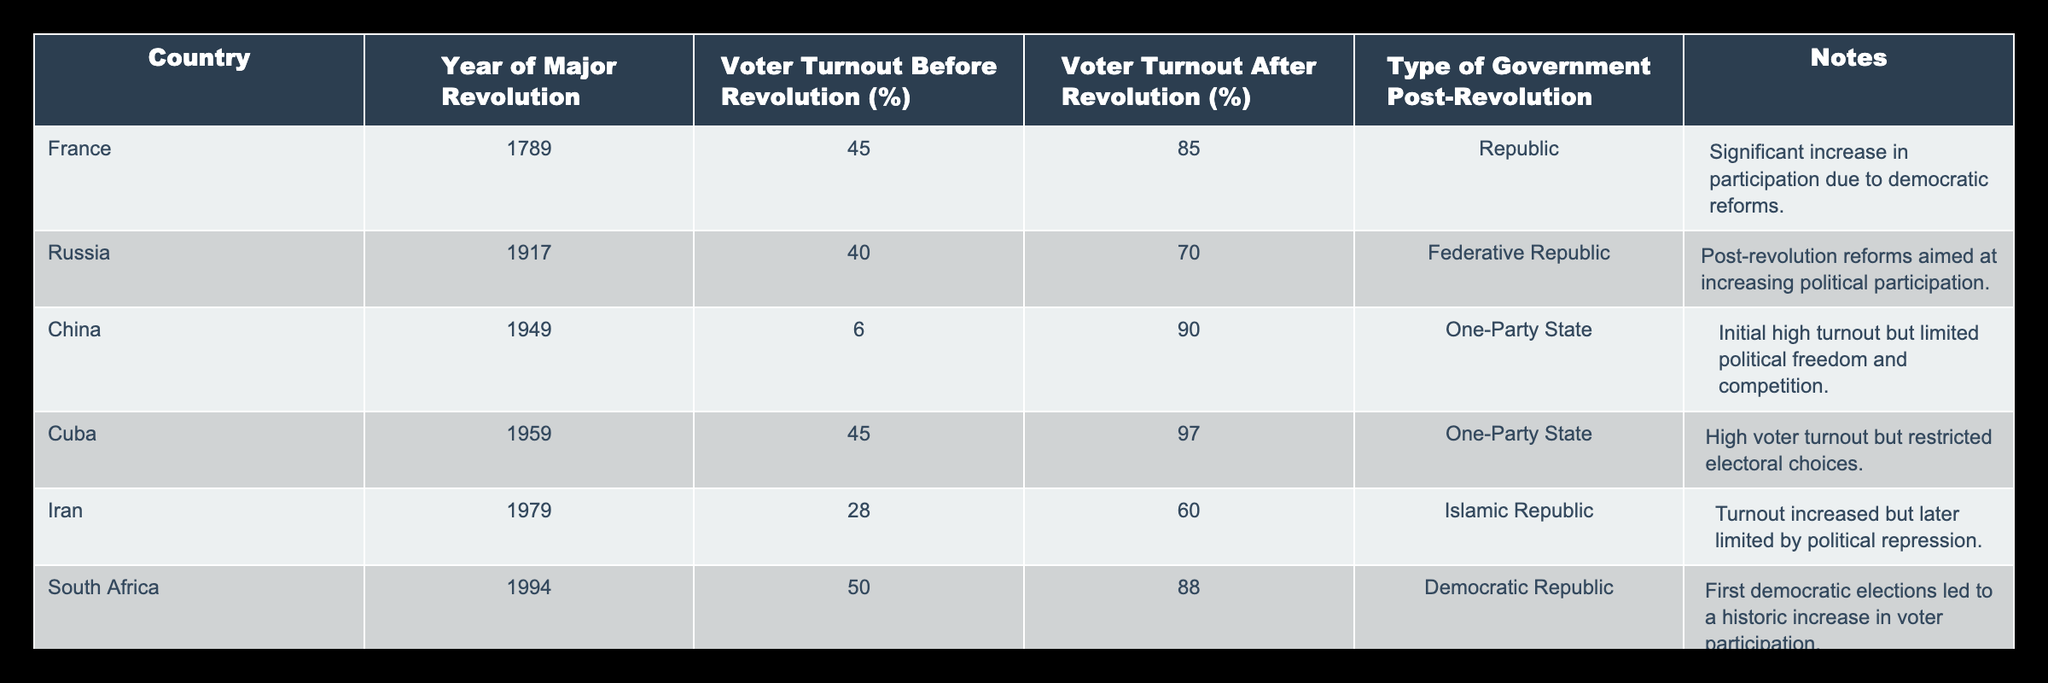What was the voter turnout in France before the revolution? The table indicates that the voter turnout in France before the revolution in 1789 was 45%.
Answer: 45% What type of government did South Africa have after its major revolution? According to the table, South Africa established a Democratic Republic after its revolution in 1994.
Answer: Democratic Republic Which country experienced the highest voter turnout after their revolution? The data shows that China had a voter turnout of 90% after the revolution in 1949, which is the highest among all listed countries.
Answer: China What is the difference in voter turnout in Cuba before and after the revolution? The voter turnout in Cuba before the revolution was 45% and after it was 97%. The difference is calculated as 97% - 45% = 52%.
Answer: 52% Did Iran's voter turnout increase after the revolution? The table shows that Iran's voter turnout increased from 28% before the revolution to 60% after the revolution, indicating an increase.
Answer: Yes What was the average voter turnout before the revolutions across these nations? To find the average, sum the voter turnouts before the revolutions: 45 + 40 + 6 + 45 + 28 + 50 = 214. There are 6 nations, so the average is 214/6 = approximately 35.67%.
Answer: 35.67% In which type of government did the most significant increase in voter turnout occur? Analyzing the data, Cuba saw an increase from 45% to 97%, resulting in an increase of 52%, which is the most significant increase among all countries listed.
Answer: One-Party State Which two countries had a voter turnout of at least 60% after their revolutions? The table shows that South Africa (88%) and China (90%) had a voter turnout of at least 60% after their revolutions.
Answer: South Africa and China Was the voter turnout in Russia higher after the revolution or before it? The data clearly states that the voter turnout in Russia increased from 40% before the revolution to 70% after it, showing a higher turnout afterward.
Answer: Higher after 